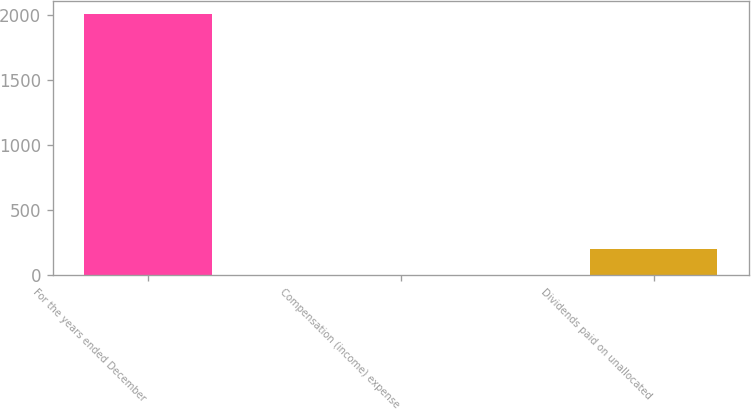<chart> <loc_0><loc_0><loc_500><loc_500><bar_chart><fcel>For the years ended December<fcel>Compensation (income) expense<fcel>Dividends paid on unallocated<nl><fcel>2005<fcel>0.4<fcel>200.86<nl></chart> 